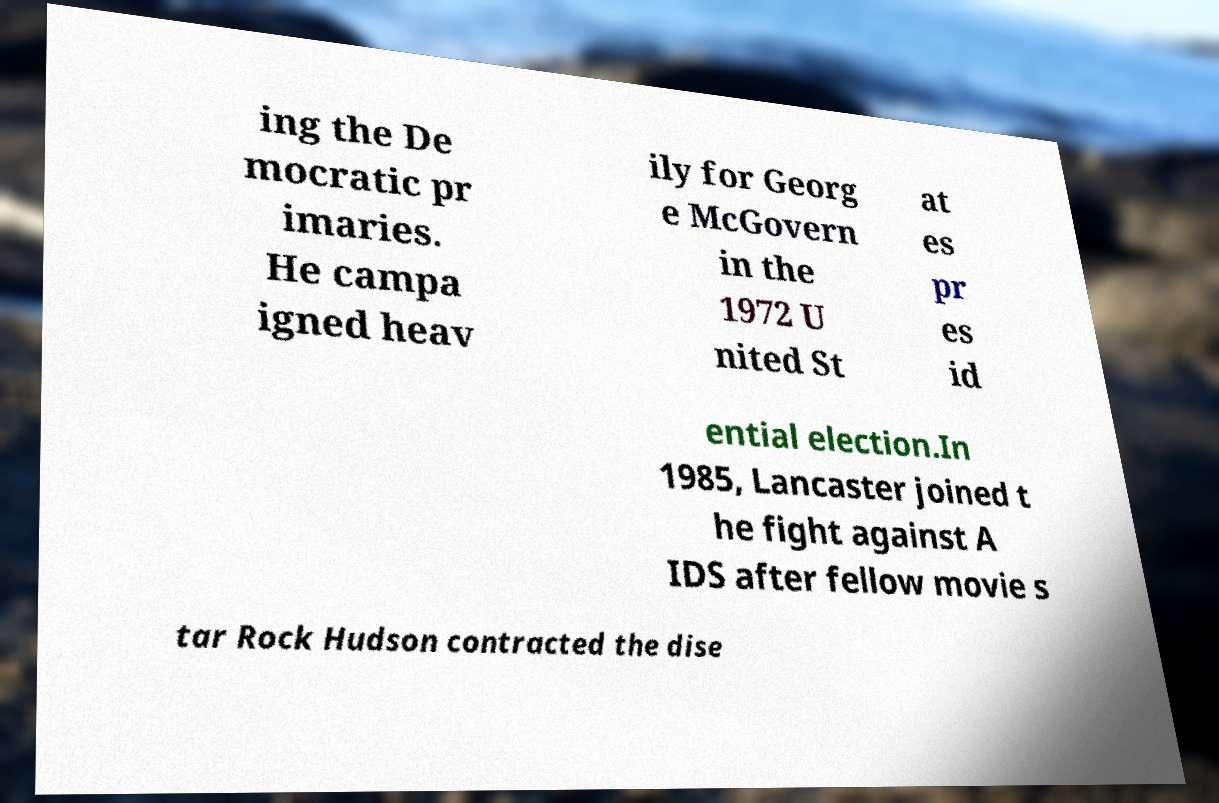Could you assist in decoding the text presented in this image and type it out clearly? ing the De mocratic pr imaries. He campa igned heav ily for Georg e McGovern in the 1972 U nited St at es pr es id ential election.In 1985, Lancaster joined t he fight against A IDS after fellow movie s tar Rock Hudson contracted the dise 